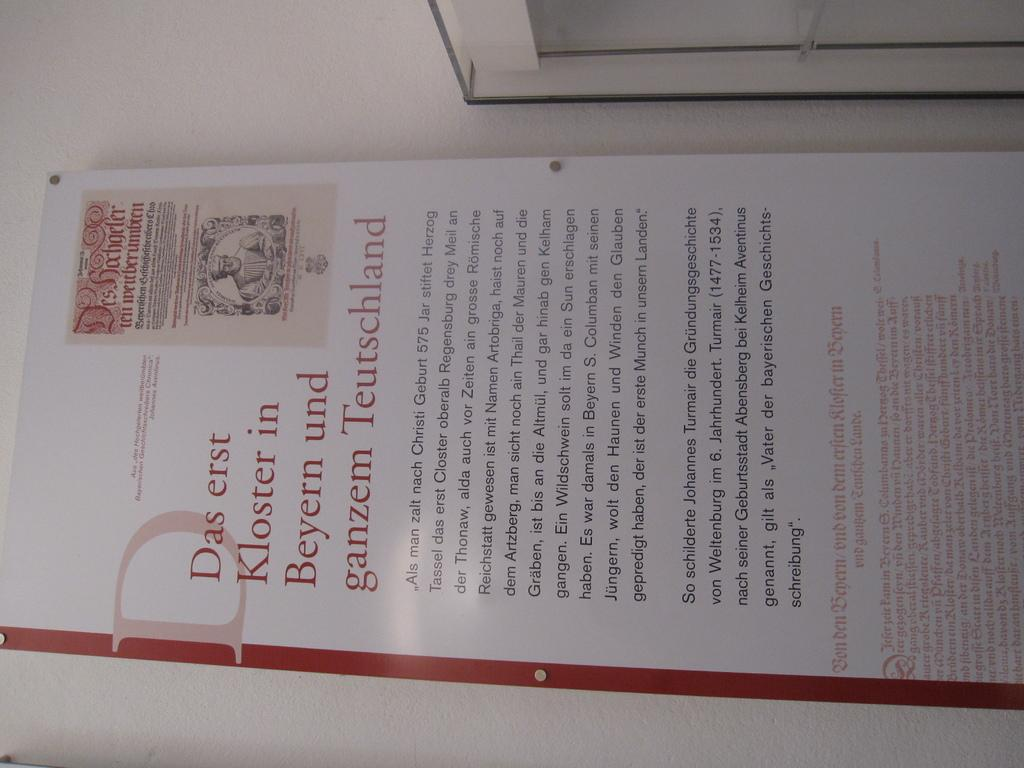<image>
Share a concise interpretation of the image provided. A poster attached to a wall contains the words Das erst Kloster in Beyern und ganzem Teutschland. 